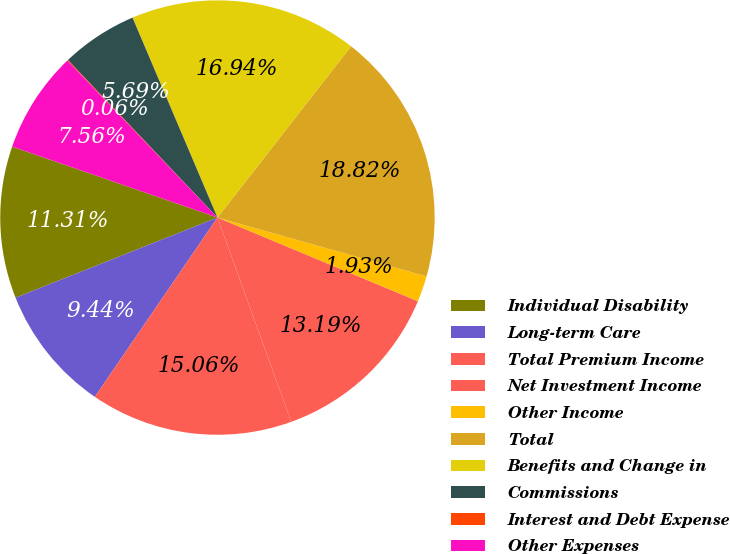<chart> <loc_0><loc_0><loc_500><loc_500><pie_chart><fcel>Individual Disability<fcel>Long-term Care<fcel>Total Premium Income<fcel>Net Investment Income<fcel>Other Income<fcel>Total<fcel>Benefits and Change in<fcel>Commissions<fcel>Interest and Debt Expense<fcel>Other Expenses<nl><fcel>11.31%<fcel>9.44%<fcel>15.06%<fcel>13.19%<fcel>1.93%<fcel>18.82%<fcel>16.94%<fcel>5.69%<fcel>0.06%<fcel>7.56%<nl></chart> 